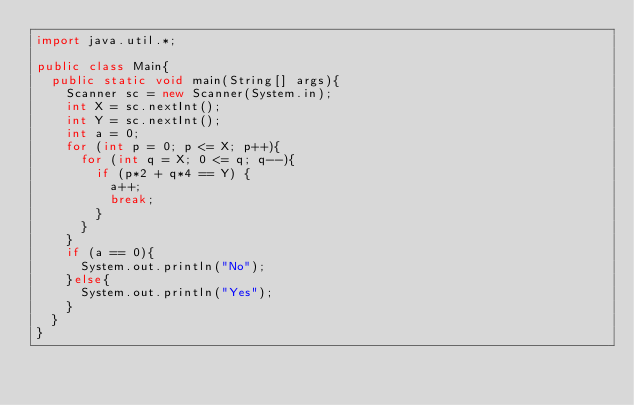Convert code to text. <code><loc_0><loc_0><loc_500><loc_500><_Java_>import java.util.*;

public class Main{
  public static void main(String[] args){
    Scanner sc = new Scanner(System.in);
    int X = sc.nextInt();
    int Y = sc.nextInt();
    int a = 0;
    for (int p = 0; p <= X; p++){
      for (int q = X; 0 <= q; q--){
        if (p*2 + q*4 == Y) {
          a++;
          break;
        }
      }
    }
    if (a == 0){
      System.out.println("No");
    }else{
      System.out.println("Yes");
    }
  }
}</code> 